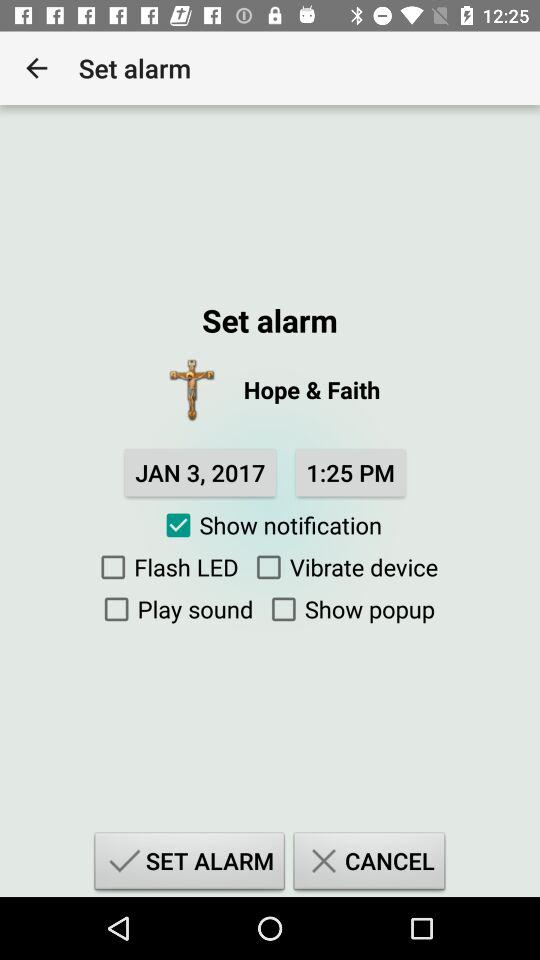What is the name of the application?
When the provided information is insufficient, respond with <no answer>. <no answer> 